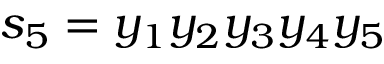<formula> <loc_0><loc_0><loc_500><loc_500>s _ { 5 } = y _ { 1 } y _ { 2 } y _ { 3 } y _ { 4 } y _ { 5 }</formula> 